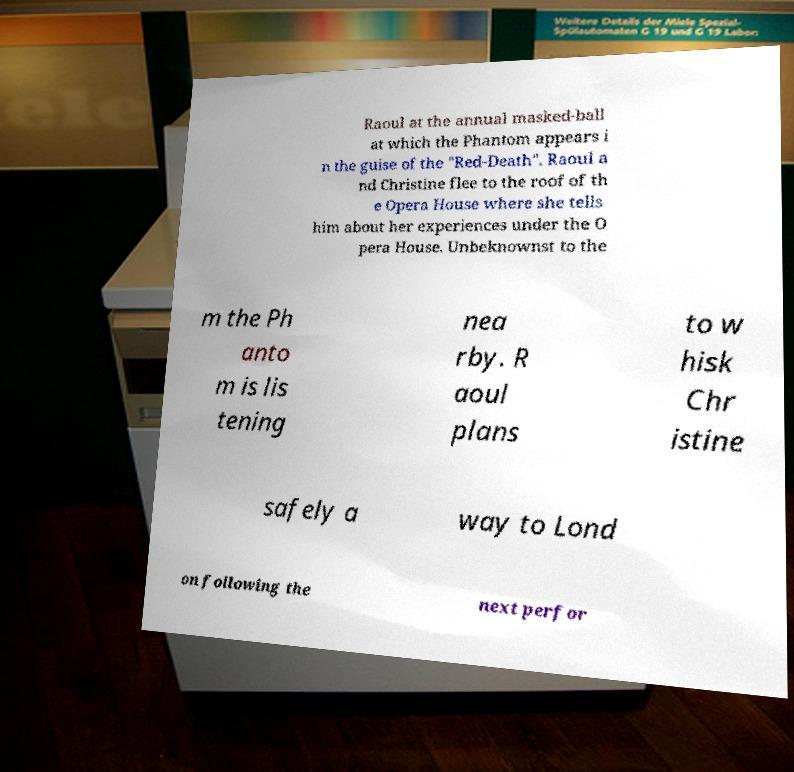Could you extract and type out the text from this image? Raoul at the annual masked-ball at which the Phantom appears i n the guise of the "Red-Death". Raoul a nd Christine flee to the roof of th e Opera House where she tells him about her experiences under the O pera House. Unbeknownst to the m the Ph anto m is lis tening nea rby. R aoul plans to w hisk Chr istine safely a way to Lond on following the next perfor 